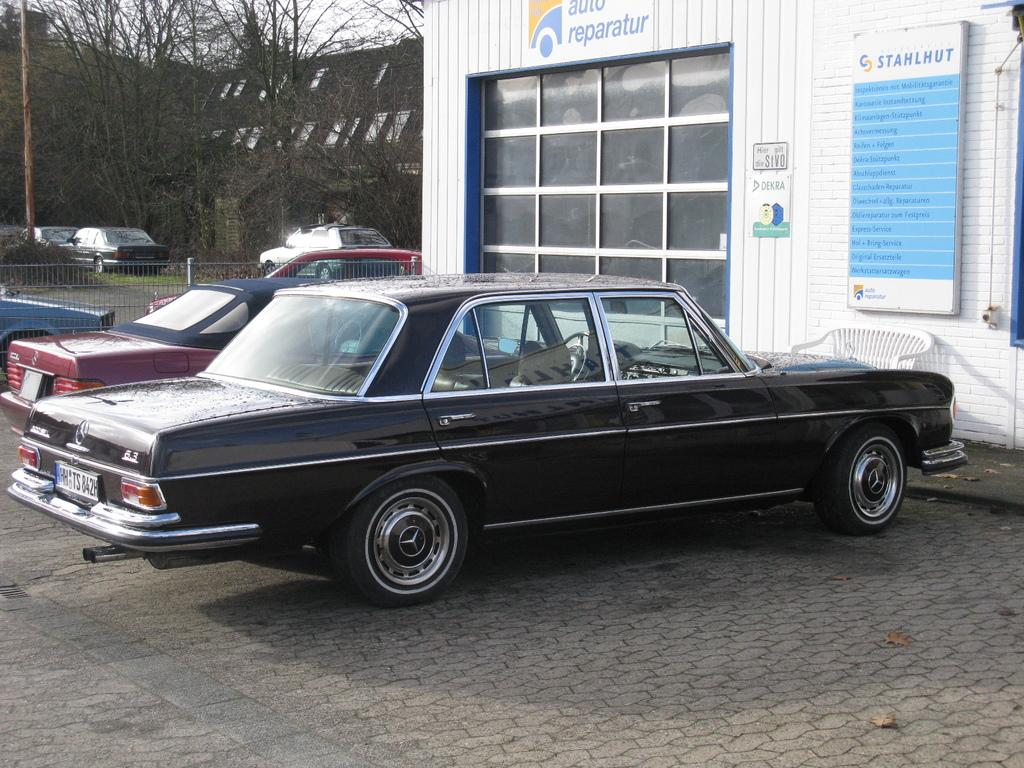What is located in front of the building in the image? There are vehicles parked in front of a building. What can be seen in the background of the image? There are trees and other vehicles visible in the background. What type of poison is being used to fertilize the rose in the image? There is no rose or poison present in the image. How many eggs are visible in the image? There are no eggs visible in the image. 